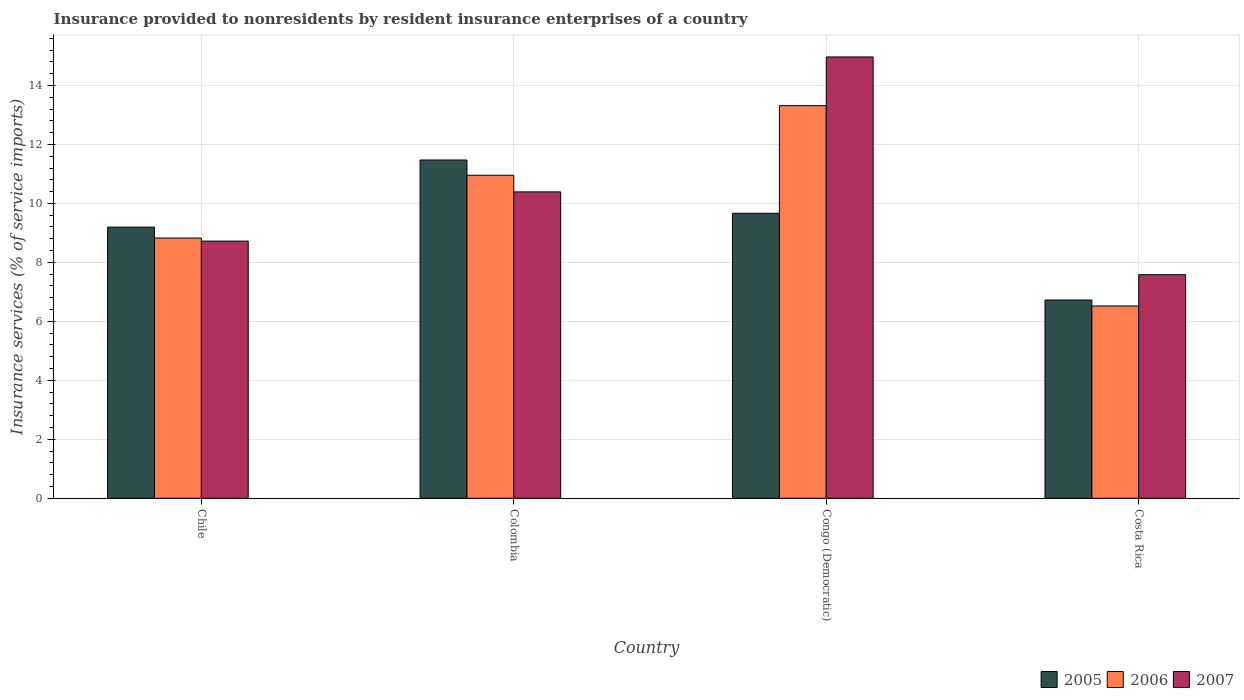How many different coloured bars are there?
Your answer should be compact. 3. Are the number of bars on each tick of the X-axis equal?
Ensure brevity in your answer.  Yes. How many bars are there on the 4th tick from the left?
Your answer should be compact. 3. How many bars are there on the 2nd tick from the right?
Provide a short and direct response. 3. In how many cases, is the number of bars for a given country not equal to the number of legend labels?
Make the answer very short. 0. What is the insurance provided to nonresidents in 2007 in Congo (Democratic)?
Your answer should be compact. 14.97. Across all countries, what is the maximum insurance provided to nonresidents in 2006?
Your answer should be very brief. 13.31. Across all countries, what is the minimum insurance provided to nonresidents in 2005?
Make the answer very short. 6.72. In which country was the insurance provided to nonresidents in 2006 maximum?
Your response must be concise. Congo (Democratic). In which country was the insurance provided to nonresidents in 2007 minimum?
Keep it short and to the point. Costa Rica. What is the total insurance provided to nonresidents in 2007 in the graph?
Give a very brief answer. 41.66. What is the difference between the insurance provided to nonresidents in 2007 in Chile and that in Congo (Democratic)?
Provide a succinct answer. -6.25. What is the difference between the insurance provided to nonresidents in 2005 in Costa Rica and the insurance provided to nonresidents in 2006 in Chile?
Keep it short and to the point. -2.1. What is the average insurance provided to nonresidents in 2006 per country?
Make the answer very short. 9.9. What is the difference between the insurance provided to nonresidents of/in 2006 and insurance provided to nonresidents of/in 2007 in Colombia?
Your answer should be compact. 0.56. What is the ratio of the insurance provided to nonresidents in 2006 in Chile to that in Colombia?
Your answer should be very brief. 0.81. Is the insurance provided to nonresidents in 2007 in Congo (Democratic) less than that in Costa Rica?
Provide a succinct answer. No. What is the difference between the highest and the second highest insurance provided to nonresidents in 2005?
Provide a succinct answer. -1.81. What is the difference between the highest and the lowest insurance provided to nonresidents in 2006?
Make the answer very short. 6.79. In how many countries, is the insurance provided to nonresidents in 2005 greater than the average insurance provided to nonresidents in 2005 taken over all countries?
Keep it short and to the point. 2. What does the 1st bar from the left in Chile represents?
Keep it short and to the point. 2005. What does the 3rd bar from the right in Costa Rica represents?
Offer a terse response. 2005. Are all the bars in the graph horizontal?
Make the answer very short. No. Does the graph contain any zero values?
Your answer should be compact. No. What is the title of the graph?
Give a very brief answer. Insurance provided to nonresidents by resident insurance enterprises of a country. Does "2006" appear as one of the legend labels in the graph?
Provide a short and direct response. Yes. What is the label or title of the Y-axis?
Offer a very short reply. Insurance services (% of service imports). What is the Insurance services (% of service imports) of 2005 in Chile?
Your answer should be compact. 9.2. What is the Insurance services (% of service imports) of 2006 in Chile?
Your answer should be compact. 8.83. What is the Insurance services (% of service imports) of 2007 in Chile?
Ensure brevity in your answer.  8.72. What is the Insurance services (% of service imports) of 2005 in Colombia?
Your response must be concise. 11.47. What is the Insurance services (% of service imports) of 2006 in Colombia?
Offer a terse response. 10.96. What is the Insurance services (% of service imports) of 2007 in Colombia?
Your response must be concise. 10.39. What is the Insurance services (% of service imports) in 2005 in Congo (Democratic)?
Make the answer very short. 9.66. What is the Insurance services (% of service imports) in 2006 in Congo (Democratic)?
Your answer should be very brief. 13.31. What is the Insurance services (% of service imports) in 2007 in Congo (Democratic)?
Keep it short and to the point. 14.97. What is the Insurance services (% of service imports) of 2005 in Costa Rica?
Your answer should be compact. 6.72. What is the Insurance services (% of service imports) of 2006 in Costa Rica?
Keep it short and to the point. 6.52. What is the Insurance services (% of service imports) in 2007 in Costa Rica?
Keep it short and to the point. 7.58. Across all countries, what is the maximum Insurance services (% of service imports) in 2005?
Offer a very short reply. 11.47. Across all countries, what is the maximum Insurance services (% of service imports) of 2006?
Provide a short and direct response. 13.31. Across all countries, what is the maximum Insurance services (% of service imports) in 2007?
Provide a short and direct response. 14.97. Across all countries, what is the minimum Insurance services (% of service imports) of 2005?
Keep it short and to the point. 6.72. Across all countries, what is the minimum Insurance services (% of service imports) in 2006?
Make the answer very short. 6.52. Across all countries, what is the minimum Insurance services (% of service imports) in 2007?
Your response must be concise. 7.58. What is the total Insurance services (% of service imports) of 2005 in the graph?
Offer a terse response. 37.06. What is the total Insurance services (% of service imports) of 2006 in the graph?
Make the answer very short. 39.62. What is the total Insurance services (% of service imports) in 2007 in the graph?
Offer a very short reply. 41.66. What is the difference between the Insurance services (% of service imports) of 2005 in Chile and that in Colombia?
Offer a terse response. -2.28. What is the difference between the Insurance services (% of service imports) in 2006 in Chile and that in Colombia?
Keep it short and to the point. -2.13. What is the difference between the Insurance services (% of service imports) in 2007 in Chile and that in Colombia?
Give a very brief answer. -1.67. What is the difference between the Insurance services (% of service imports) of 2005 in Chile and that in Congo (Democratic)?
Offer a very short reply. -0.47. What is the difference between the Insurance services (% of service imports) in 2006 in Chile and that in Congo (Democratic)?
Your answer should be compact. -4.49. What is the difference between the Insurance services (% of service imports) in 2007 in Chile and that in Congo (Democratic)?
Provide a short and direct response. -6.25. What is the difference between the Insurance services (% of service imports) of 2005 in Chile and that in Costa Rica?
Ensure brevity in your answer.  2.47. What is the difference between the Insurance services (% of service imports) in 2006 in Chile and that in Costa Rica?
Offer a very short reply. 2.3. What is the difference between the Insurance services (% of service imports) of 2007 in Chile and that in Costa Rica?
Provide a succinct answer. 1.14. What is the difference between the Insurance services (% of service imports) in 2005 in Colombia and that in Congo (Democratic)?
Offer a terse response. 1.81. What is the difference between the Insurance services (% of service imports) in 2006 in Colombia and that in Congo (Democratic)?
Make the answer very short. -2.36. What is the difference between the Insurance services (% of service imports) of 2007 in Colombia and that in Congo (Democratic)?
Your answer should be very brief. -4.58. What is the difference between the Insurance services (% of service imports) of 2005 in Colombia and that in Costa Rica?
Provide a short and direct response. 4.75. What is the difference between the Insurance services (% of service imports) in 2006 in Colombia and that in Costa Rica?
Your answer should be compact. 4.43. What is the difference between the Insurance services (% of service imports) in 2007 in Colombia and that in Costa Rica?
Your answer should be very brief. 2.81. What is the difference between the Insurance services (% of service imports) in 2005 in Congo (Democratic) and that in Costa Rica?
Your answer should be compact. 2.94. What is the difference between the Insurance services (% of service imports) in 2006 in Congo (Democratic) and that in Costa Rica?
Your answer should be very brief. 6.79. What is the difference between the Insurance services (% of service imports) of 2007 in Congo (Democratic) and that in Costa Rica?
Offer a terse response. 7.38. What is the difference between the Insurance services (% of service imports) of 2005 in Chile and the Insurance services (% of service imports) of 2006 in Colombia?
Give a very brief answer. -1.76. What is the difference between the Insurance services (% of service imports) of 2005 in Chile and the Insurance services (% of service imports) of 2007 in Colombia?
Provide a short and direct response. -1.19. What is the difference between the Insurance services (% of service imports) of 2006 in Chile and the Insurance services (% of service imports) of 2007 in Colombia?
Your response must be concise. -1.57. What is the difference between the Insurance services (% of service imports) of 2005 in Chile and the Insurance services (% of service imports) of 2006 in Congo (Democratic)?
Give a very brief answer. -4.12. What is the difference between the Insurance services (% of service imports) in 2005 in Chile and the Insurance services (% of service imports) in 2007 in Congo (Democratic)?
Make the answer very short. -5.77. What is the difference between the Insurance services (% of service imports) in 2006 in Chile and the Insurance services (% of service imports) in 2007 in Congo (Democratic)?
Offer a terse response. -6.14. What is the difference between the Insurance services (% of service imports) in 2005 in Chile and the Insurance services (% of service imports) in 2006 in Costa Rica?
Make the answer very short. 2.67. What is the difference between the Insurance services (% of service imports) in 2005 in Chile and the Insurance services (% of service imports) in 2007 in Costa Rica?
Offer a very short reply. 1.61. What is the difference between the Insurance services (% of service imports) of 2006 in Chile and the Insurance services (% of service imports) of 2007 in Costa Rica?
Provide a short and direct response. 1.24. What is the difference between the Insurance services (% of service imports) in 2005 in Colombia and the Insurance services (% of service imports) in 2006 in Congo (Democratic)?
Provide a short and direct response. -1.84. What is the difference between the Insurance services (% of service imports) in 2005 in Colombia and the Insurance services (% of service imports) in 2007 in Congo (Democratic)?
Offer a terse response. -3.49. What is the difference between the Insurance services (% of service imports) of 2006 in Colombia and the Insurance services (% of service imports) of 2007 in Congo (Democratic)?
Your answer should be compact. -4.01. What is the difference between the Insurance services (% of service imports) of 2005 in Colombia and the Insurance services (% of service imports) of 2006 in Costa Rica?
Ensure brevity in your answer.  4.95. What is the difference between the Insurance services (% of service imports) in 2005 in Colombia and the Insurance services (% of service imports) in 2007 in Costa Rica?
Provide a short and direct response. 3.89. What is the difference between the Insurance services (% of service imports) in 2006 in Colombia and the Insurance services (% of service imports) in 2007 in Costa Rica?
Your answer should be very brief. 3.37. What is the difference between the Insurance services (% of service imports) of 2005 in Congo (Democratic) and the Insurance services (% of service imports) of 2006 in Costa Rica?
Provide a succinct answer. 3.14. What is the difference between the Insurance services (% of service imports) of 2005 in Congo (Democratic) and the Insurance services (% of service imports) of 2007 in Costa Rica?
Offer a very short reply. 2.08. What is the difference between the Insurance services (% of service imports) in 2006 in Congo (Democratic) and the Insurance services (% of service imports) in 2007 in Costa Rica?
Ensure brevity in your answer.  5.73. What is the average Insurance services (% of service imports) in 2005 per country?
Give a very brief answer. 9.26. What is the average Insurance services (% of service imports) in 2006 per country?
Offer a very short reply. 9.9. What is the average Insurance services (% of service imports) of 2007 per country?
Your answer should be compact. 10.42. What is the difference between the Insurance services (% of service imports) of 2005 and Insurance services (% of service imports) of 2006 in Chile?
Your answer should be compact. 0.37. What is the difference between the Insurance services (% of service imports) of 2005 and Insurance services (% of service imports) of 2007 in Chile?
Your response must be concise. 0.47. What is the difference between the Insurance services (% of service imports) of 2006 and Insurance services (% of service imports) of 2007 in Chile?
Offer a very short reply. 0.1. What is the difference between the Insurance services (% of service imports) in 2005 and Insurance services (% of service imports) in 2006 in Colombia?
Offer a terse response. 0.52. What is the difference between the Insurance services (% of service imports) of 2005 and Insurance services (% of service imports) of 2007 in Colombia?
Your answer should be very brief. 1.08. What is the difference between the Insurance services (% of service imports) in 2006 and Insurance services (% of service imports) in 2007 in Colombia?
Your answer should be compact. 0.56. What is the difference between the Insurance services (% of service imports) of 2005 and Insurance services (% of service imports) of 2006 in Congo (Democratic)?
Keep it short and to the point. -3.65. What is the difference between the Insurance services (% of service imports) of 2005 and Insurance services (% of service imports) of 2007 in Congo (Democratic)?
Your answer should be compact. -5.3. What is the difference between the Insurance services (% of service imports) in 2006 and Insurance services (% of service imports) in 2007 in Congo (Democratic)?
Ensure brevity in your answer.  -1.65. What is the difference between the Insurance services (% of service imports) in 2005 and Insurance services (% of service imports) in 2006 in Costa Rica?
Offer a very short reply. 0.2. What is the difference between the Insurance services (% of service imports) in 2005 and Insurance services (% of service imports) in 2007 in Costa Rica?
Make the answer very short. -0.86. What is the difference between the Insurance services (% of service imports) in 2006 and Insurance services (% of service imports) in 2007 in Costa Rica?
Offer a terse response. -1.06. What is the ratio of the Insurance services (% of service imports) of 2005 in Chile to that in Colombia?
Provide a short and direct response. 0.8. What is the ratio of the Insurance services (% of service imports) in 2006 in Chile to that in Colombia?
Your response must be concise. 0.81. What is the ratio of the Insurance services (% of service imports) of 2007 in Chile to that in Colombia?
Ensure brevity in your answer.  0.84. What is the ratio of the Insurance services (% of service imports) of 2005 in Chile to that in Congo (Democratic)?
Give a very brief answer. 0.95. What is the ratio of the Insurance services (% of service imports) of 2006 in Chile to that in Congo (Democratic)?
Your response must be concise. 0.66. What is the ratio of the Insurance services (% of service imports) in 2007 in Chile to that in Congo (Democratic)?
Offer a terse response. 0.58. What is the ratio of the Insurance services (% of service imports) in 2005 in Chile to that in Costa Rica?
Offer a terse response. 1.37. What is the ratio of the Insurance services (% of service imports) of 2006 in Chile to that in Costa Rica?
Your response must be concise. 1.35. What is the ratio of the Insurance services (% of service imports) in 2007 in Chile to that in Costa Rica?
Give a very brief answer. 1.15. What is the ratio of the Insurance services (% of service imports) of 2005 in Colombia to that in Congo (Democratic)?
Your answer should be compact. 1.19. What is the ratio of the Insurance services (% of service imports) in 2006 in Colombia to that in Congo (Democratic)?
Ensure brevity in your answer.  0.82. What is the ratio of the Insurance services (% of service imports) in 2007 in Colombia to that in Congo (Democratic)?
Offer a very short reply. 0.69. What is the ratio of the Insurance services (% of service imports) of 2005 in Colombia to that in Costa Rica?
Offer a very short reply. 1.71. What is the ratio of the Insurance services (% of service imports) of 2006 in Colombia to that in Costa Rica?
Offer a very short reply. 1.68. What is the ratio of the Insurance services (% of service imports) of 2007 in Colombia to that in Costa Rica?
Your answer should be compact. 1.37. What is the ratio of the Insurance services (% of service imports) of 2005 in Congo (Democratic) to that in Costa Rica?
Provide a short and direct response. 1.44. What is the ratio of the Insurance services (% of service imports) in 2006 in Congo (Democratic) to that in Costa Rica?
Your answer should be very brief. 2.04. What is the ratio of the Insurance services (% of service imports) in 2007 in Congo (Democratic) to that in Costa Rica?
Keep it short and to the point. 1.97. What is the difference between the highest and the second highest Insurance services (% of service imports) of 2005?
Provide a short and direct response. 1.81. What is the difference between the highest and the second highest Insurance services (% of service imports) in 2006?
Ensure brevity in your answer.  2.36. What is the difference between the highest and the second highest Insurance services (% of service imports) in 2007?
Make the answer very short. 4.58. What is the difference between the highest and the lowest Insurance services (% of service imports) of 2005?
Give a very brief answer. 4.75. What is the difference between the highest and the lowest Insurance services (% of service imports) in 2006?
Keep it short and to the point. 6.79. What is the difference between the highest and the lowest Insurance services (% of service imports) of 2007?
Offer a terse response. 7.38. 